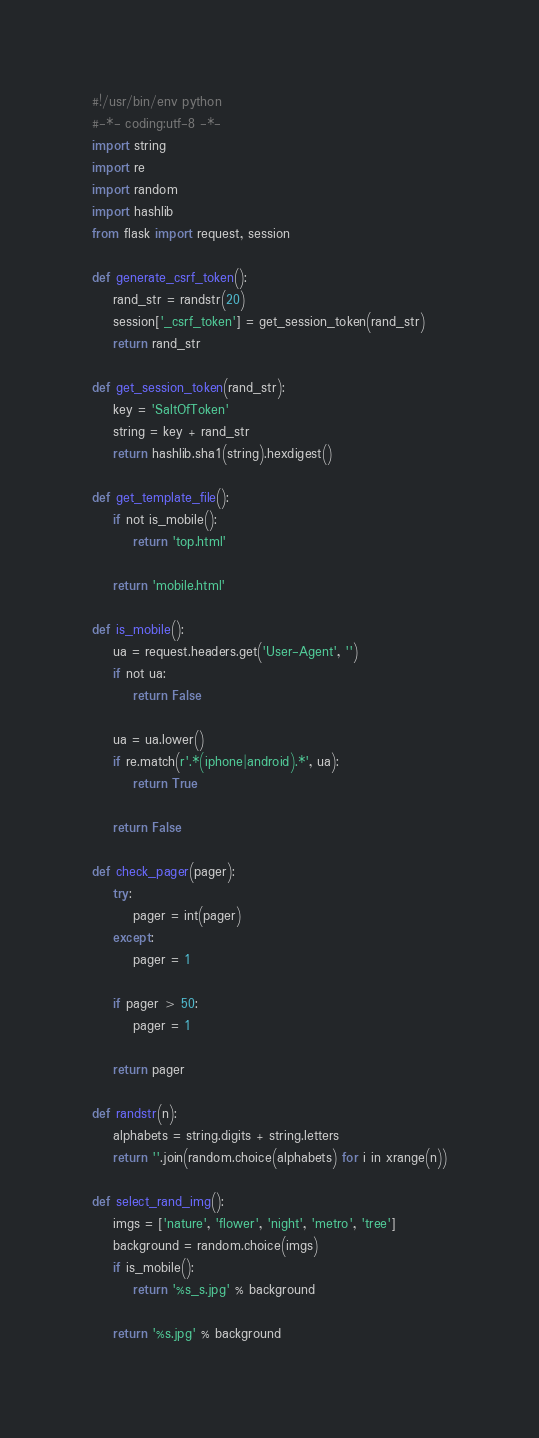Convert code to text. <code><loc_0><loc_0><loc_500><loc_500><_Python_>#!/usr/bin/env python
#-*- coding:utf-8 -*-
import string
import re
import random
import hashlib
from flask import request, session

def generate_csrf_token():
    rand_str = randstr(20)
    session['_csrf_token'] = get_session_token(rand_str)
    return rand_str

def get_session_token(rand_str):
    key = 'SaltOfToken'
    string = key + rand_str
    return hashlib.sha1(string).hexdigest()

def get_template_file():
    if not is_mobile():
        return 'top.html'

    return 'mobile.html'

def is_mobile():
    ua = request.headers.get('User-Agent', '')
    if not ua:
        return False

    ua = ua.lower()
    if re.match(r'.*(iphone|android).*', ua):
        return True

    return False

def check_pager(pager):
    try:
        pager = int(pager)
    except:
        pager = 1

    if pager > 50:
        pager = 1

    return pager

def randstr(n):
    alphabets = string.digits + string.letters
    return ''.join(random.choice(alphabets) for i in xrange(n))

def select_rand_img():
    imgs = ['nature', 'flower', 'night', 'metro', 'tree']
    background = random.choice(imgs)
    if is_mobile():
        return '%s_s.jpg' % background

    return '%s.jpg' % background

</code> 